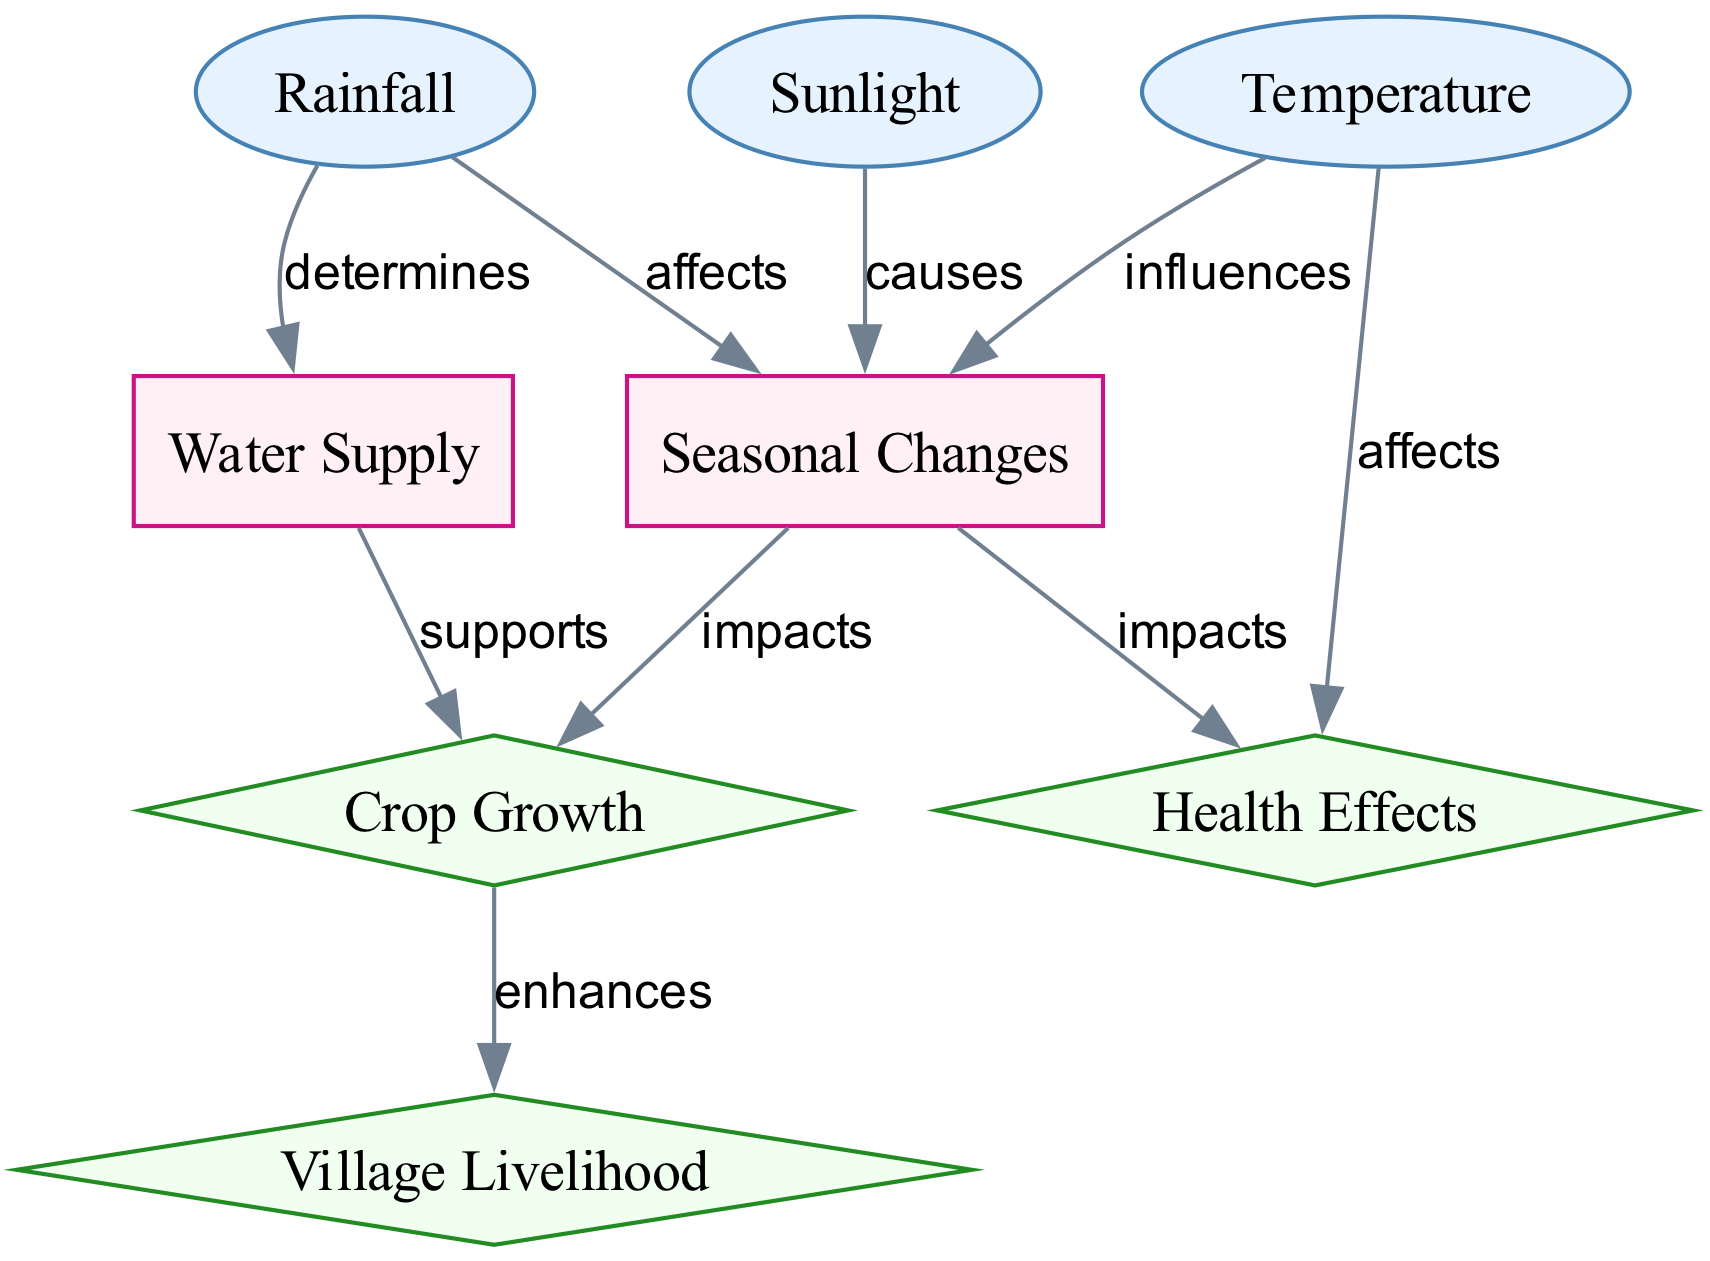What are the three input nodes in the diagram? The diagram contains three input nodes: sunlight, temperature, and rainfall. To identify them, we can look for nodes labeled as 'input' in the diagram's description. Each of these nodes represents key environmental factors influencing weather patterns.
Answer: sunlight, temperature, rainfall How many output nodes are present in the diagram? The diagram features three output nodes: crop growth, village livelihood, and health effects. Counting the nodes categorized as 'output' gives us the total.
Answer: 3 What does rainfall determine? The diagram indicates that rainfall determines the water supply. By following the directed edge from rainfall to water supply, we see that this relationship is explicitly stated in the edge description.
Answer: water supply Which node has the label "supports"? The edge labeled "supports" connects the water supply node to the crop growth node. This indicates that the water supply is essential for supporting the growth of crops, as shown in the flow of the diagram.
Answer: crop growth What is the impact of seasonal changes on crop growth? The edge labeled "impacts" shows that seasonal changes directly affect crop growth. By tracing the flow from seasonal changes to crop growth, we understand that seasonal variations influence agricultural productivity in the village.
Answer: impacts How does temperature affect health? The diagram shows two edges leading from temperature to health, indicating that temperature affects health in both direct and indirect ways. This can be understood by considering how temperature variations can influence health conditions within the village context.
Answer: affects What is the relationship between seasonal changes and health effects? The relationship is marked by an edge labeled "impacts." This signifies that seasonal changes in weather can have significant effects on the health of the villagers, likely through factors like food availability and disease prevalence.
Answer: impacts What enhances village livelihood? The diagram indicates that crop growth enhances village livelihood through an edge labeled "enhances." The link shows the critical dependency of village income and sustenance on successful agricultural practices.
Answer: crop growth 